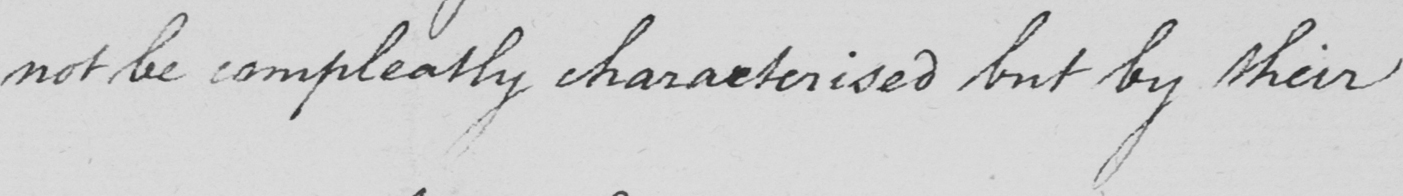Can you tell me what this handwritten text says? not be compleatly characterised but by their 